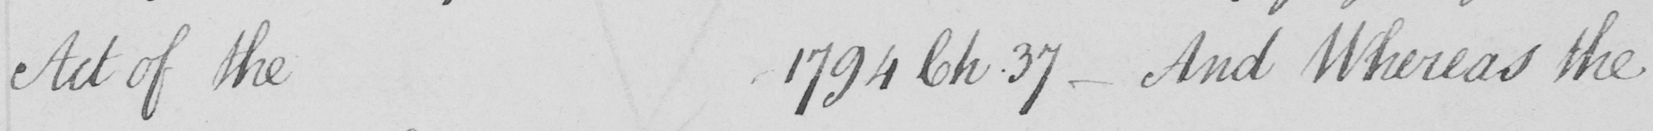Can you read and transcribe this handwriting? Act of the 1794 Ch . 37  _  And Whereas the 